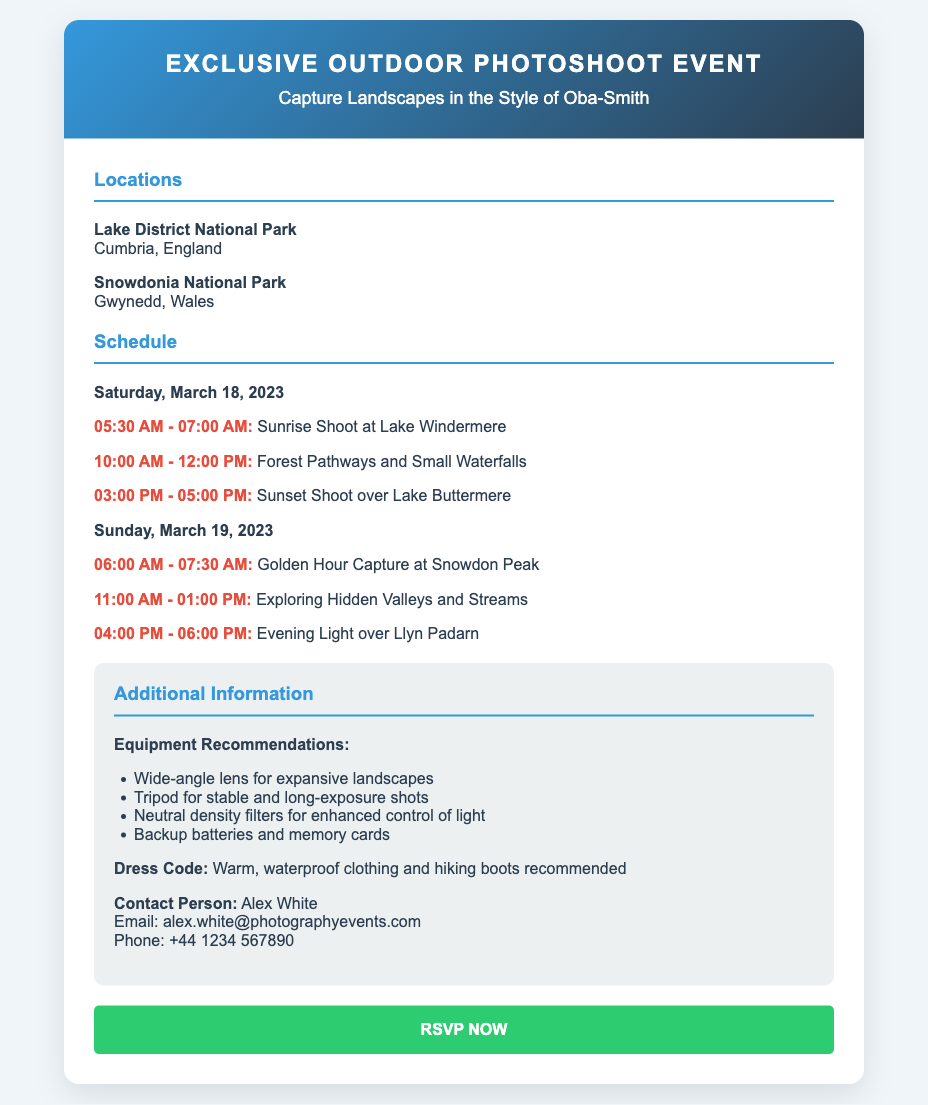What is the title of the event? The title of the event is prominently displayed at the top of the card.
Answer: Exclusive Outdoor Photoshoot Event What is the date of the first session? The date of the first session can be found in the schedule section of the document.
Answer: Saturday, March 18, 2023 Where will the sunrise shoot take place? The location for the sunrise shoot is mentioned in the session details for the first day.
Answer: Lake Windermere What time does the evening light session start on the second day? The starting time for the evening light session on the second day is specified in the schedule.
Answer: 04:00 PM What should participants wear? The recommended dress code is provided in the additional information section of the card.
Answer: Warm, waterproof clothing and hiking boots How many sessions are there on Sunday? By reviewing the schedule, we can count the number of sessions on Sunday.
Answer: Three sessions Who is the contact person for the event? The document mentions the contact person in the additional information section.
Answer: Alex White What type of lens is suggested for the landscape photoshoot? The equipment recommendations include specific lens types mentioned in the list.
Answer: Wide-angle lens 